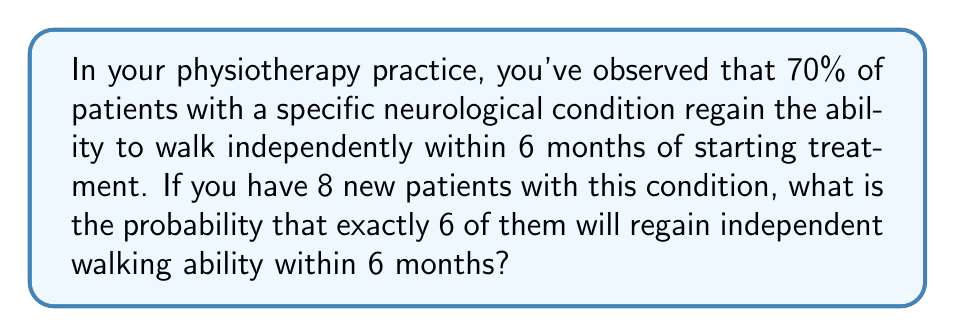Solve this math problem. To solve this problem, we need to use the binomial probability distribution, as we're dealing with a fixed number of independent trials (patients) with two possible outcomes (regain walking ability or not) and a known probability of success.

The binomial probability formula is:

$$P(X=k) = \binom{n}{k} p^k (1-p)^{n-k}$$

Where:
$n$ = number of trials (patients) = 8
$k$ = number of successes (patients regaining walking ability) = 6
$p$ = probability of success for each trial = 0.70

Step 1: Calculate the binomial coefficient $\binom{n}{k}$
$$\binom{8}{6} = \frac{8!}{6!(8-6)!} = \frac{8!}{6!2!} = 28$$

Step 2: Calculate $p^k$
$$0.70^6 = 0.1176$$

Step 3: Calculate $(1-p)^{n-k}$
$$(1-0.70)^{8-6} = 0.30^2 = 0.09$$

Step 4: Multiply the results from steps 1, 2, and 3
$$28 \times 0.1176 \times 0.09 = 0.2962$$

Therefore, the probability that exactly 6 out of 8 patients will regain independent walking ability within 6 months is approximately 0.2962 or 29.62%.
Answer: 0.2962 